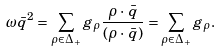Convert formula to latex. <formula><loc_0><loc_0><loc_500><loc_500>\omega \bar { q } ^ { 2 } = \sum _ { \rho \in \Delta _ { + } } g _ { \rho } { \frac { \rho \cdot \, \bar { q } } { ( \rho \cdot \, \bar { q } ) } } = \sum _ { \rho \in \Delta _ { + } } g _ { \rho } .</formula> 